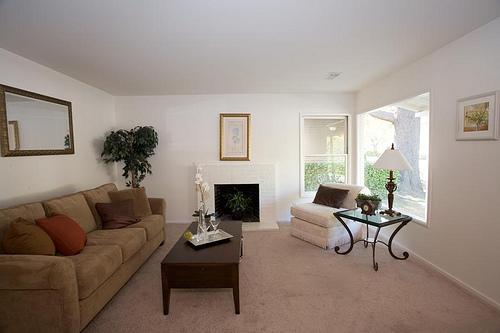What color is the chair?
Keep it brief. White. Is this a bedroom?
Give a very brief answer. No. What type of room is this?
Be succinct. Living room. Is there a mirror in the room?
Be succinct. Yes. What color is the sofa?
Give a very brief answer. Brown. Does this room have wall to wall carpeting?
Answer briefly. Yes. What color is the couch?
Concise answer only. Brown. Can this be evening?
Be succinct. No. Is the table top glass?
Be succinct. Yes. Is there a fan in the room?
Answer briefly. No. How many sofas are in the room?
Quick response, please. 1. What color is the wall?
Quick response, please. White. Is there a wooden chair?
Quick response, please. No. What is on the couch?
Concise answer only. Pillows. Is the furniture old?
Quick response, please. No. Is the lamp on?
Short answer required. No. Is there a ladder in this photo?
Give a very brief answer. No. What kind of flowers are on the window sill?
Answer briefly. None. Is the fireplace natural brick?
Quick response, please. No. What room is this?
Be succinct. Living room. How many pillows are on the couch?
Give a very brief answer. 4. 